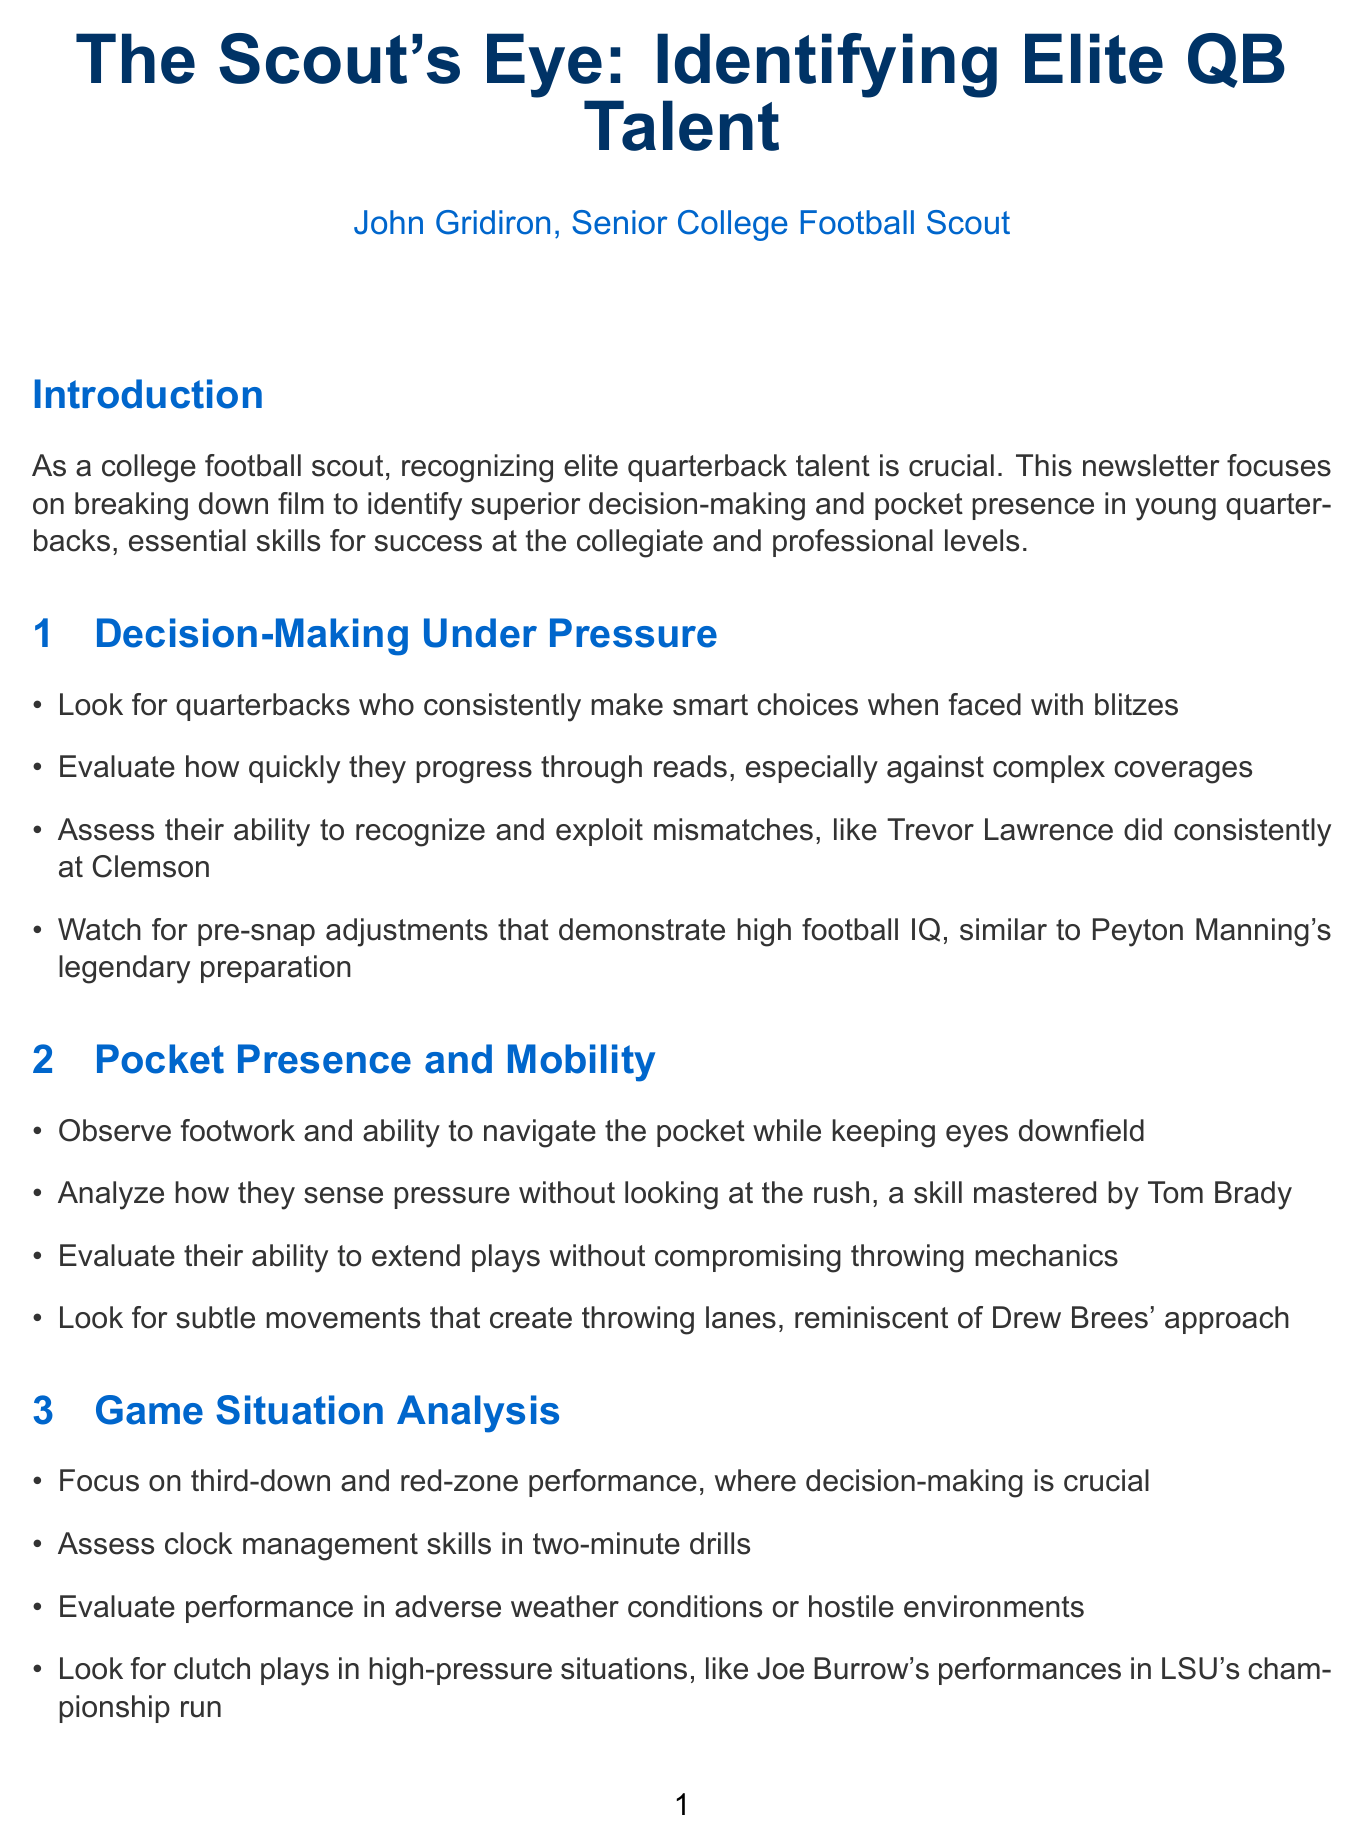what is the title of the newsletter? The title of the newsletter is presented at the beginning of the document.
Answer: The Scout's Eye: Identifying Elite QB Talent who is the author of the newsletter? The author is mentioned in the "About the Author" section of the document.
Answer: John Gridiron how many years of experience does the author have? The author's experience is stated in the "About the Author" section.
Answer: 20+ years what is one player mentioned as a notable discovery by the author? Notable discoveries are listed in the "About the Author" section.
Answer: Carson Palmer which section discusses "Game Situation Analysis"? The document has sections clearly labeled, and this title is specifically mentioned.
Answer: Game Situation Analysis which quarterback is used as a case study? The case study section identifies a specific player for analysis.
Answer: Justin Herbert what type of film is recommended for study? The "Film Study Techniques" section covers different methods, including types of film.
Answer: All-22 film which NFL team did Justin Herbert play for after college? The document mentions Herbert's team in the context of the case study.
Answer: Los Angeles Chargers what is a key skill to evaluate in pocket presence? The "Pocket Presence and Mobility" section lists specific skills to observe.
Answer: Footwork 